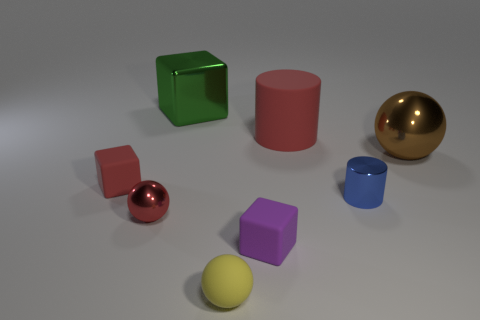What is the size of the sphere that is the same material as the big brown thing?
Your response must be concise. Small. There is a matte thing behind the brown sphere; does it have the same size as the small yellow matte ball?
Make the answer very short. No. What shape is the tiny metallic object on the left side of the cylinder that is behind the sphere behind the small red shiny thing?
Keep it short and to the point. Sphere. How many objects are tiny red rubber things or large objects that are in front of the big metallic block?
Your answer should be very brief. 3. There is a sphere right of the large red thing; what is its size?
Offer a very short reply. Large. The small metallic thing that is the same color as the big rubber cylinder is what shape?
Offer a very short reply. Sphere. Do the brown object and the block that is to the left of the green shiny block have the same material?
Your response must be concise. No. How many red things are in front of the red matte object to the right of the red thing in front of the blue thing?
Your answer should be compact. 2. How many yellow objects are either shiny objects or tiny rubber spheres?
Keep it short and to the point. 1. The large metallic object that is behind the matte cylinder has what shape?
Offer a very short reply. Cube. 